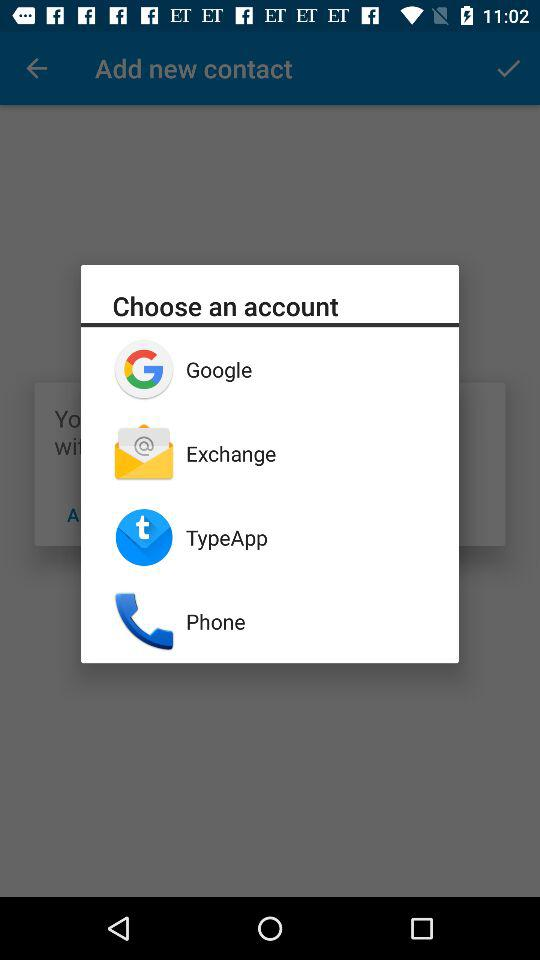Which options are given to choose an account? The options that are given to choose an account are "Google", "Exchange", "TypeApp" and "Phone". 